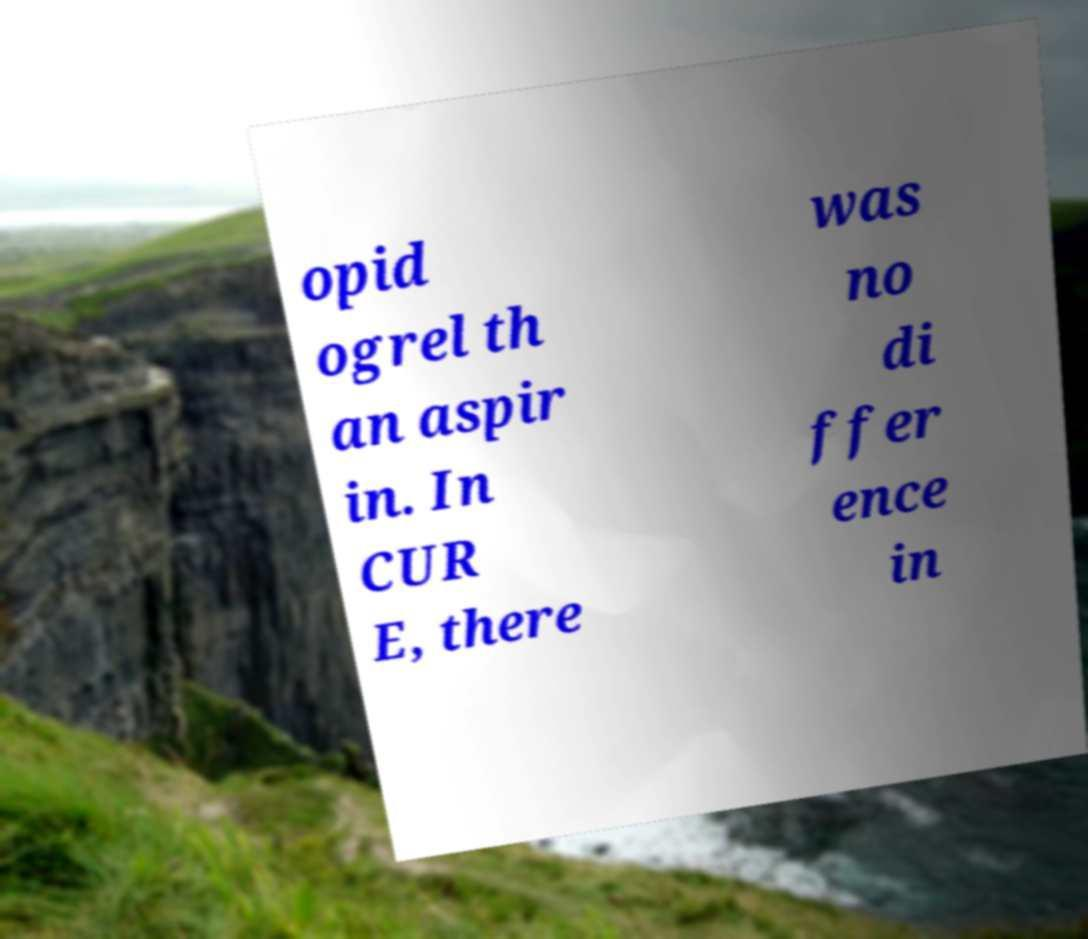Can you read and provide the text displayed in the image?This photo seems to have some interesting text. Can you extract and type it out for me? opid ogrel th an aspir in. In CUR E, there was no di ffer ence in 